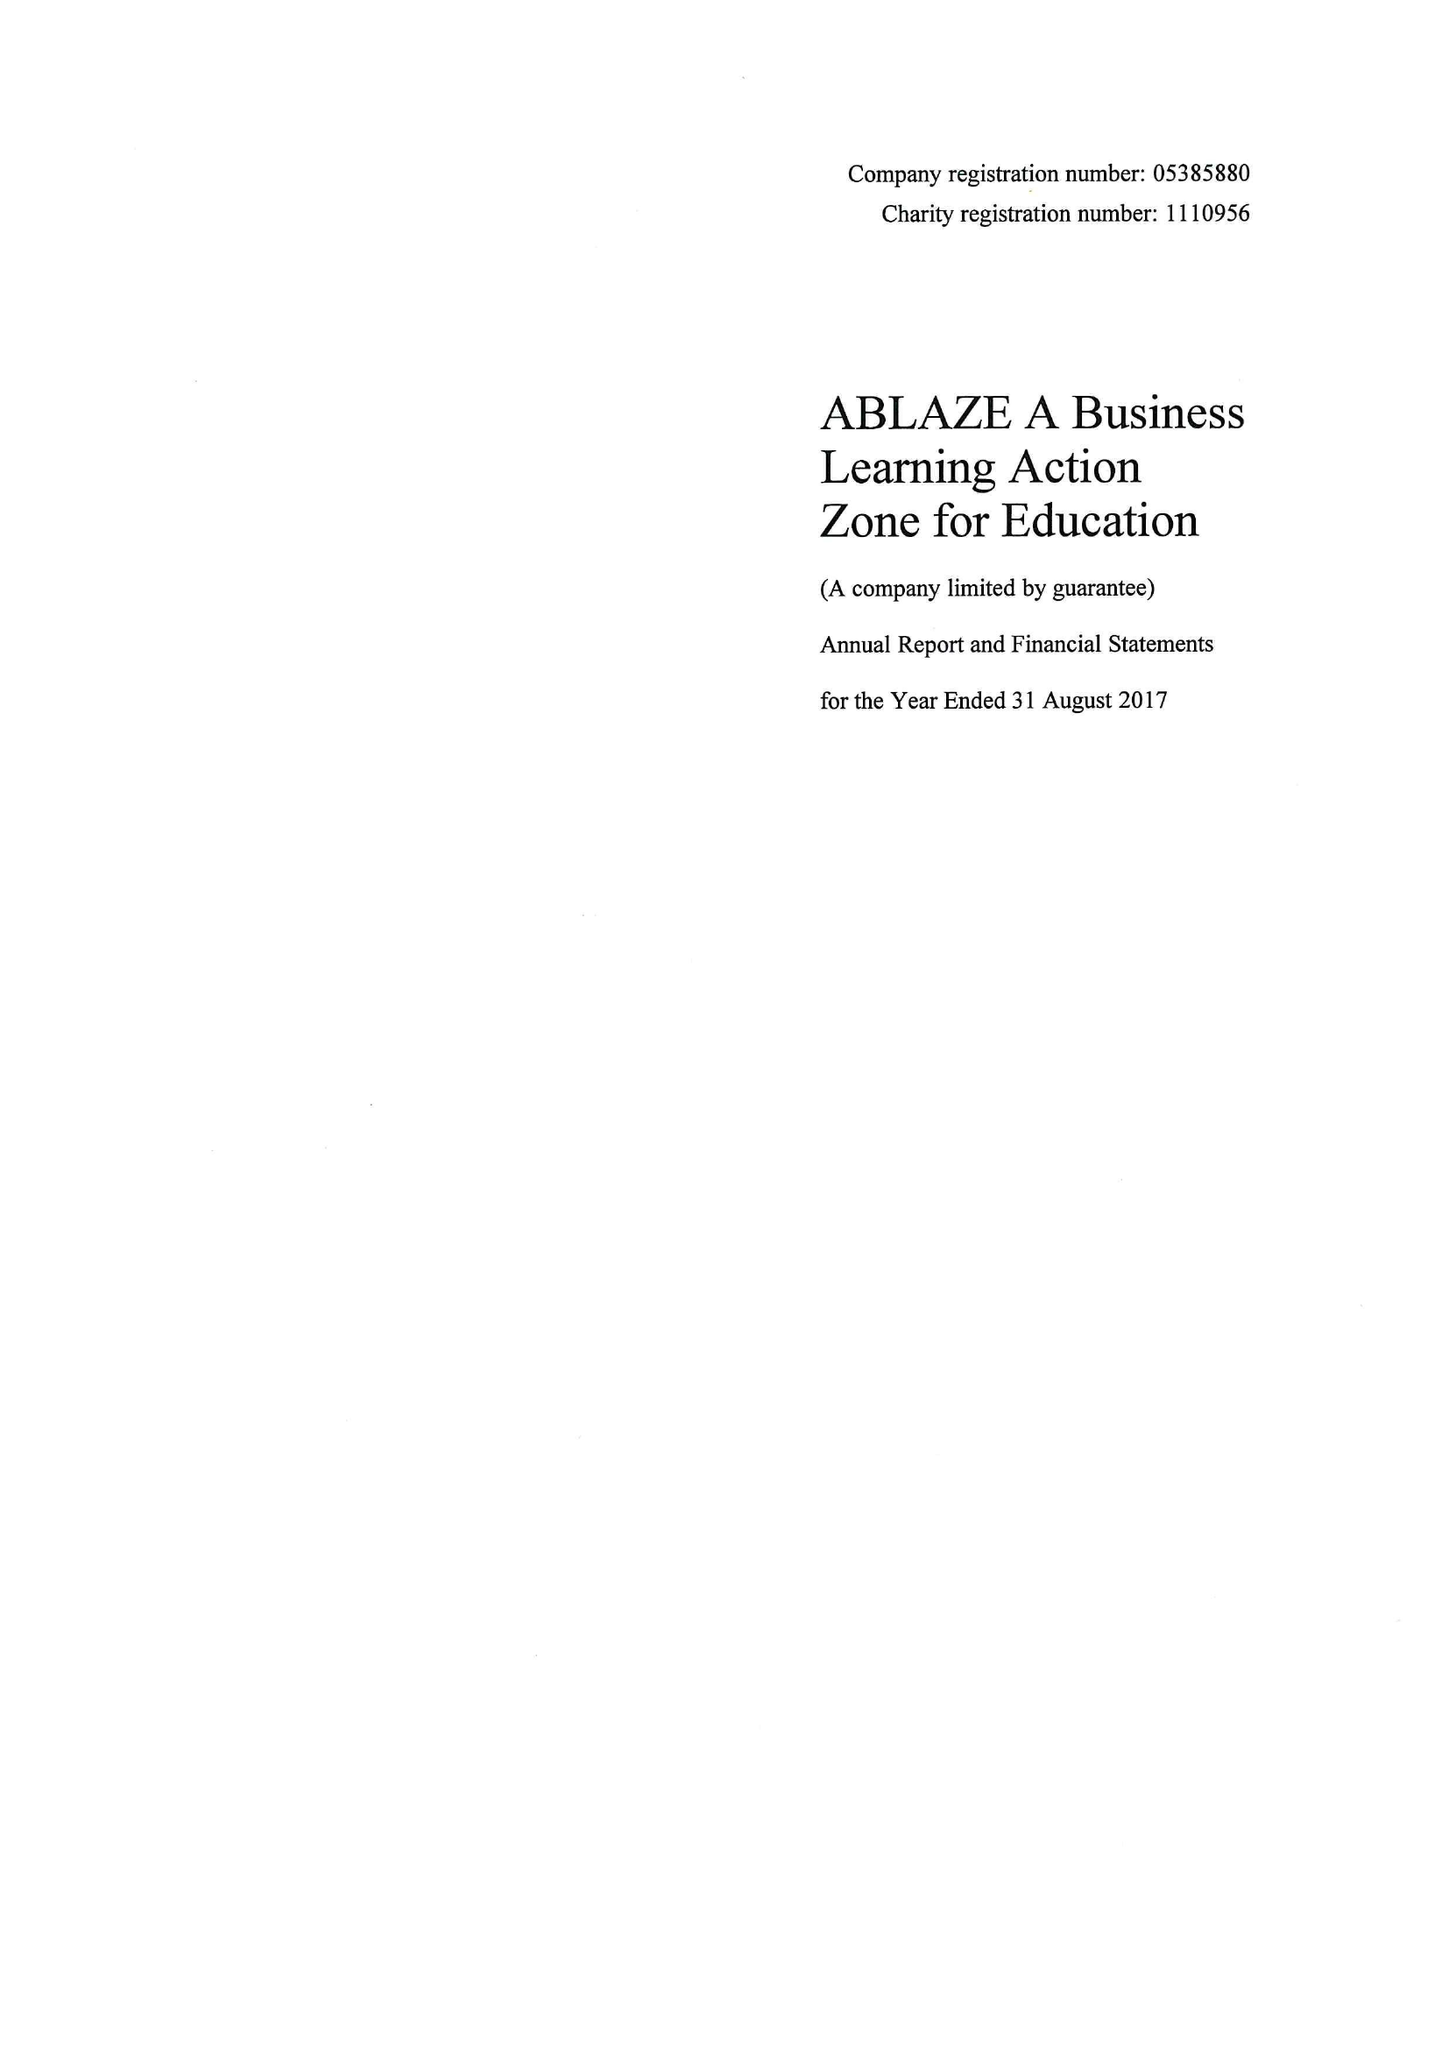What is the value for the charity_name?
Answer the question using a single word or phrase. Ablaze A Business Learning Action Zone For Education 